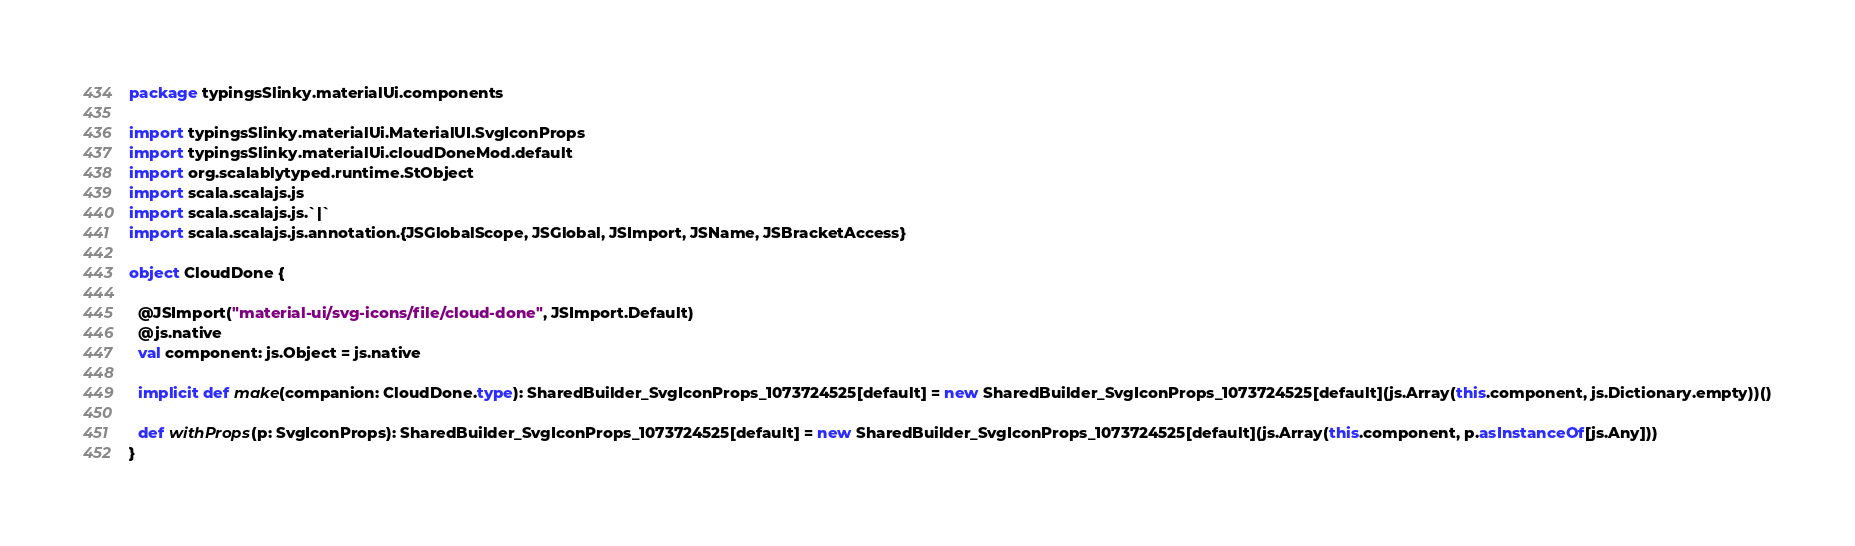Convert code to text. <code><loc_0><loc_0><loc_500><loc_500><_Scala_>package typingsSlinky.materialUi.components

import typingsSlinky.materialUi.MaterialUI.SvgIconProps
import typingsSlinky.materialUi.cloudDoneMod.default
import org.scalablytyped.runtime.StObject
import scala.scalajs.js
import scala.scalajs.js.`|`
import scala.scalajs.js.annotation.{JSGlobalScope, JSGlobal, JSImport, JSName, JSBracketAccess}

object CloudDone {
  
  @JSImport("material-ui/svg-icons/file/cloud-done", JSImport.Default)
  @js.native
  val component: js.Object = js.native
  
  implicit def make(companion: CloudDone.type): SharedBuilder_SvgIconProps_1073724525[default] = new SharedBuilder_SvgIconProps_1073724525[default](js.Array(this.component, js.Dictionary.empty))()
  
  def withProps(p: SvgIconProps): SharedBuilder_SvgIconProps_1073724525[default] = new SharedBuilder_SvgIconProps_1073724525[default](js.Array(this.component, p.asInstanceOf[js.Any]))
}
</code> 